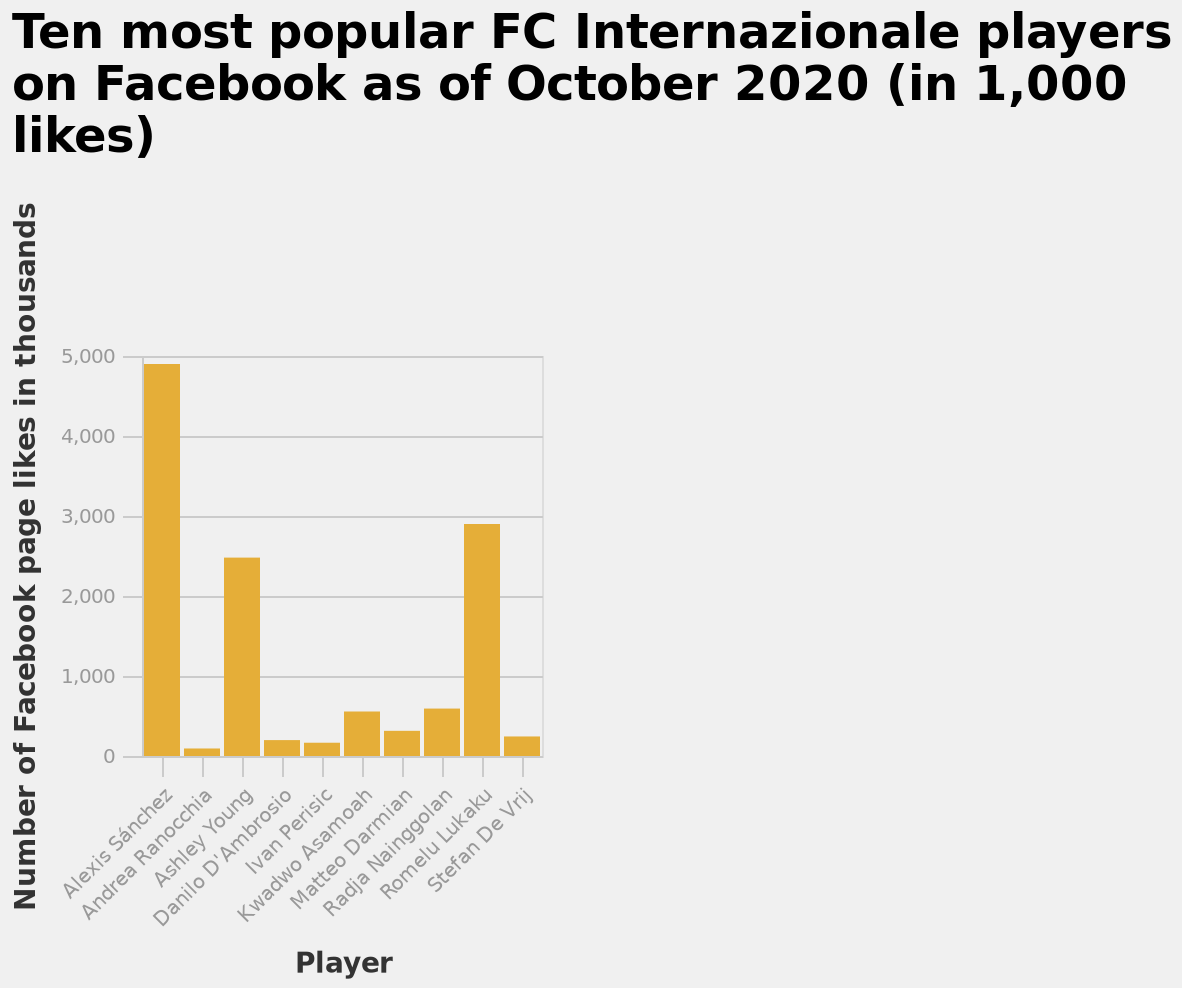<image>
What does the x-axis measure in the bar diagram?  The x-axis measures the players on a categorical scale, starting with Alexis Sánchez and ending with Stefan De Vrij. Which player is listed first on the x-axis of the bar diagram? Alexis Sánchez is listed first on the x-axis of the bar diagram. Is Alexis Sánchez listed last on the x-axis of the bar diagram? No.Alexis Sánchez is listed first on the x-axis of the bar diagram. 